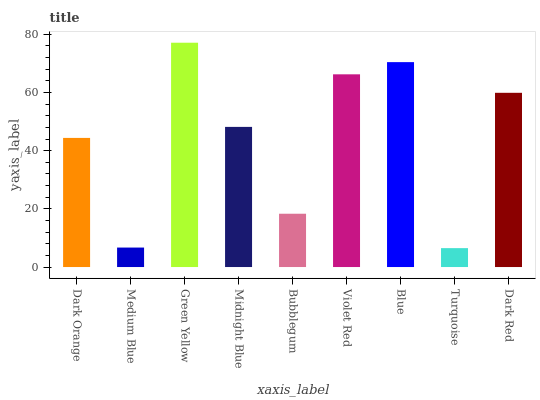Is Turquoise the minimum?
Answer yes or no. Yes. Is Green Yellow the maximum?
Answer yes or no. Yes. Is Medium Blue the minimum?
Answer yes or no. No. Is Medium Blue the maximum?
Answer yes or no. No. Is Dark Orange greater than Medium Blue?
Answer yes or no. Yes. Is Medium Blue less than Dark Orange?
Answer yes or no. Yes. Is Medium Blue greater than Dark Orange?
Answer yes or no. No. Is Dark Orange less than Medium Blue?
Answer yes or no. No. Is Midnight Blue the high median?
Answer yes or no. Yes. Is Midnight Blue the low median?
Answer yes or no. Yes. Is Bubblegum the high median?
Answer yes or no. No. Is Bubblegum the low median?
Answer yes or no. No. 